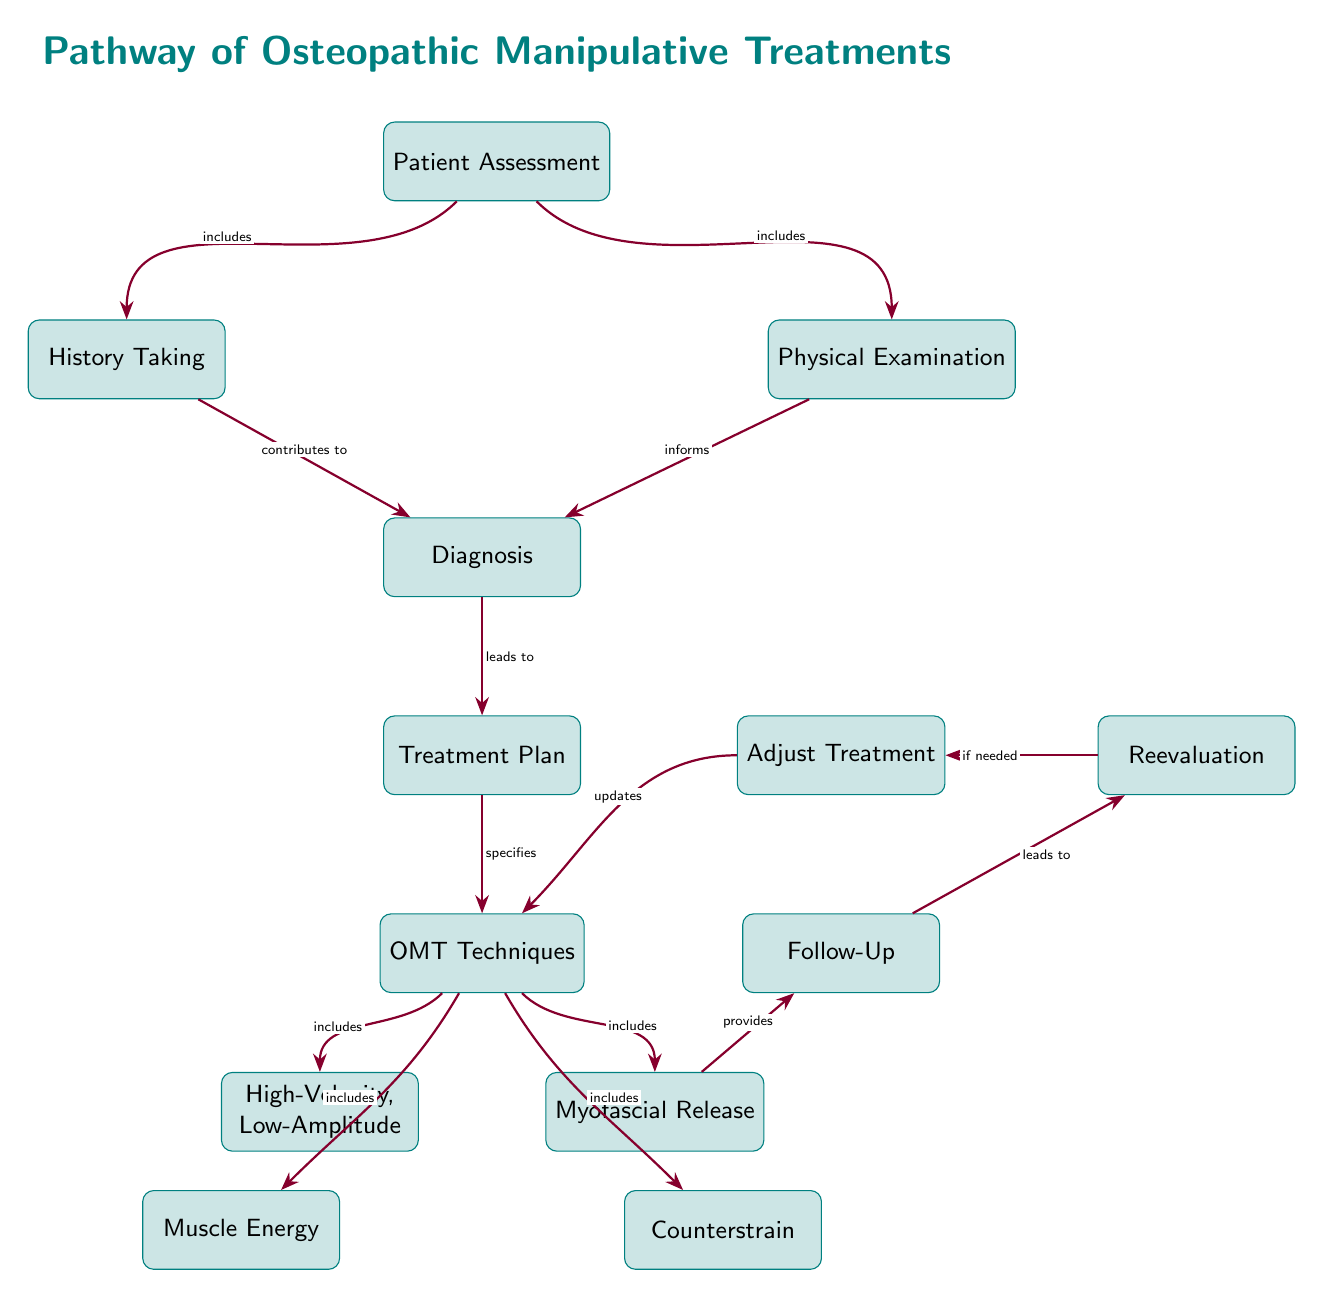What is the first step in the pathway? The first step is "Patient Assessment," as indicated at the top of the diagram.
Answer: Patient Assessment How many techniques are included under OMT Techniques? There are four specific OMT Techniques listed: High-Velocity, Low-Amplitude; Muscle Energy; Counterstrain; and Myofascial Release, as shown below the OMT Techniques node.
Answer: Four What informs the Diagnosis step? The Diagnosis step is informed by both "History Taking" and "Physical Examination," as indicated by the arrows leading into the Diagnosis node from these two nodes.
Answer: History Taking and Physical Examination What relationship does the treatment plan have with the OMT Techniques? The Treatment Plan specifies the OMT Techniques as indicated by the arrow going from the Treatment Plan to the OMT Techniques node, which shows a direct relationship.
Answer: Specifies What happens if Follow-Up indicates a need for Reevaluation? If Follow-Up indicates a need for Reevaluation, it will lead to "Adjust Treatment," as the follow-up process is depicted to potentially update the OMT Techniques based on Reevaluation.
Answer: Adjust Treatment Which technique is located directly below the OMT Techniques node? The technique directly below the OMT Techniques node is "High-Velocity, Low-Amplitude," as it is the first listed OMT technique in that section of the diagram.
Answer: High-Velocity, Low-Amplitude What leads to the Treatment Plan? The Treatment Plan is led to by the Diagnosis step, as shown by the arrow that connects them in the diagram.
Answer: Diagnosis What is the purpose of the arrow connecting Myofascial Release to Follow-Up? The arrow signifies that Myofascial Release provides a service that leads to Follow-Up, indicating that treatment impacts subsequent patient assessment steps.
Answer: Provides What would happen if Reevaluation is required? If Reevaluation is required, it leads to "Adjust Treatment," as illustrated by the flow from Reevaluation to Adjust Treatment in the diagram.
Answer: Adjust Treatment 